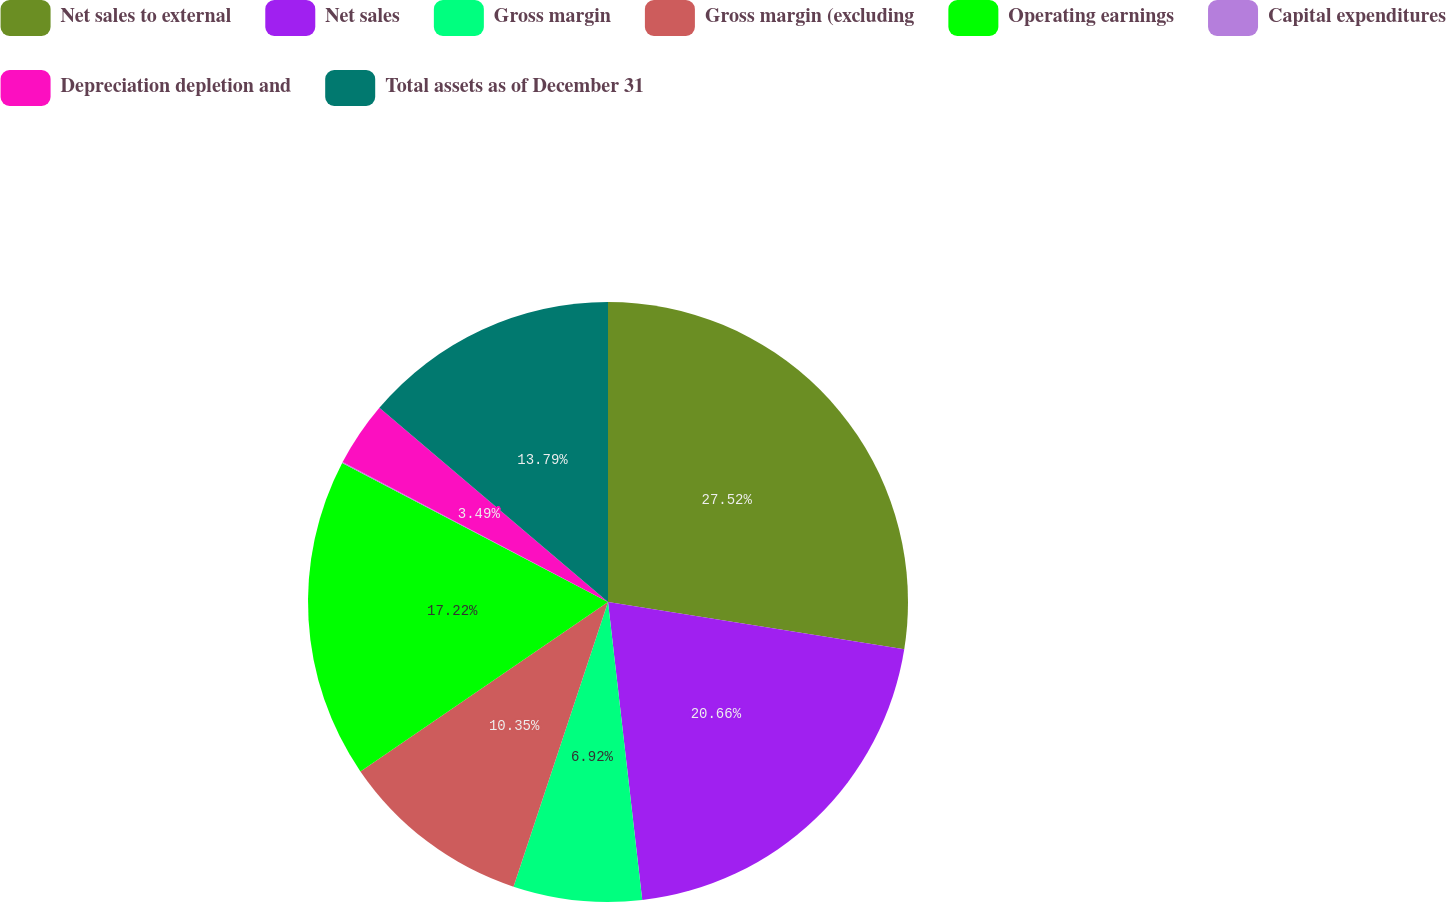<chart> <loc_0><loc_0><loc_500><loc_500><pie_chart><fcel>Net sales to external<fcel>Net sales<fcel>Gross margin<fcel>Gross margin (excluding<fcel>Operating earnings<fcel>Capital expenditures<fcel>Depreciation depletion and<fcel>Total assets as of December 31<nl><fcel>27.52%<fcel>20.66%<fcel>6.92%<fcel>10.35%<fcel>17.22%<fcel>0.05%<fcel>3.49%<fcel>13.79%<nl></chart> 